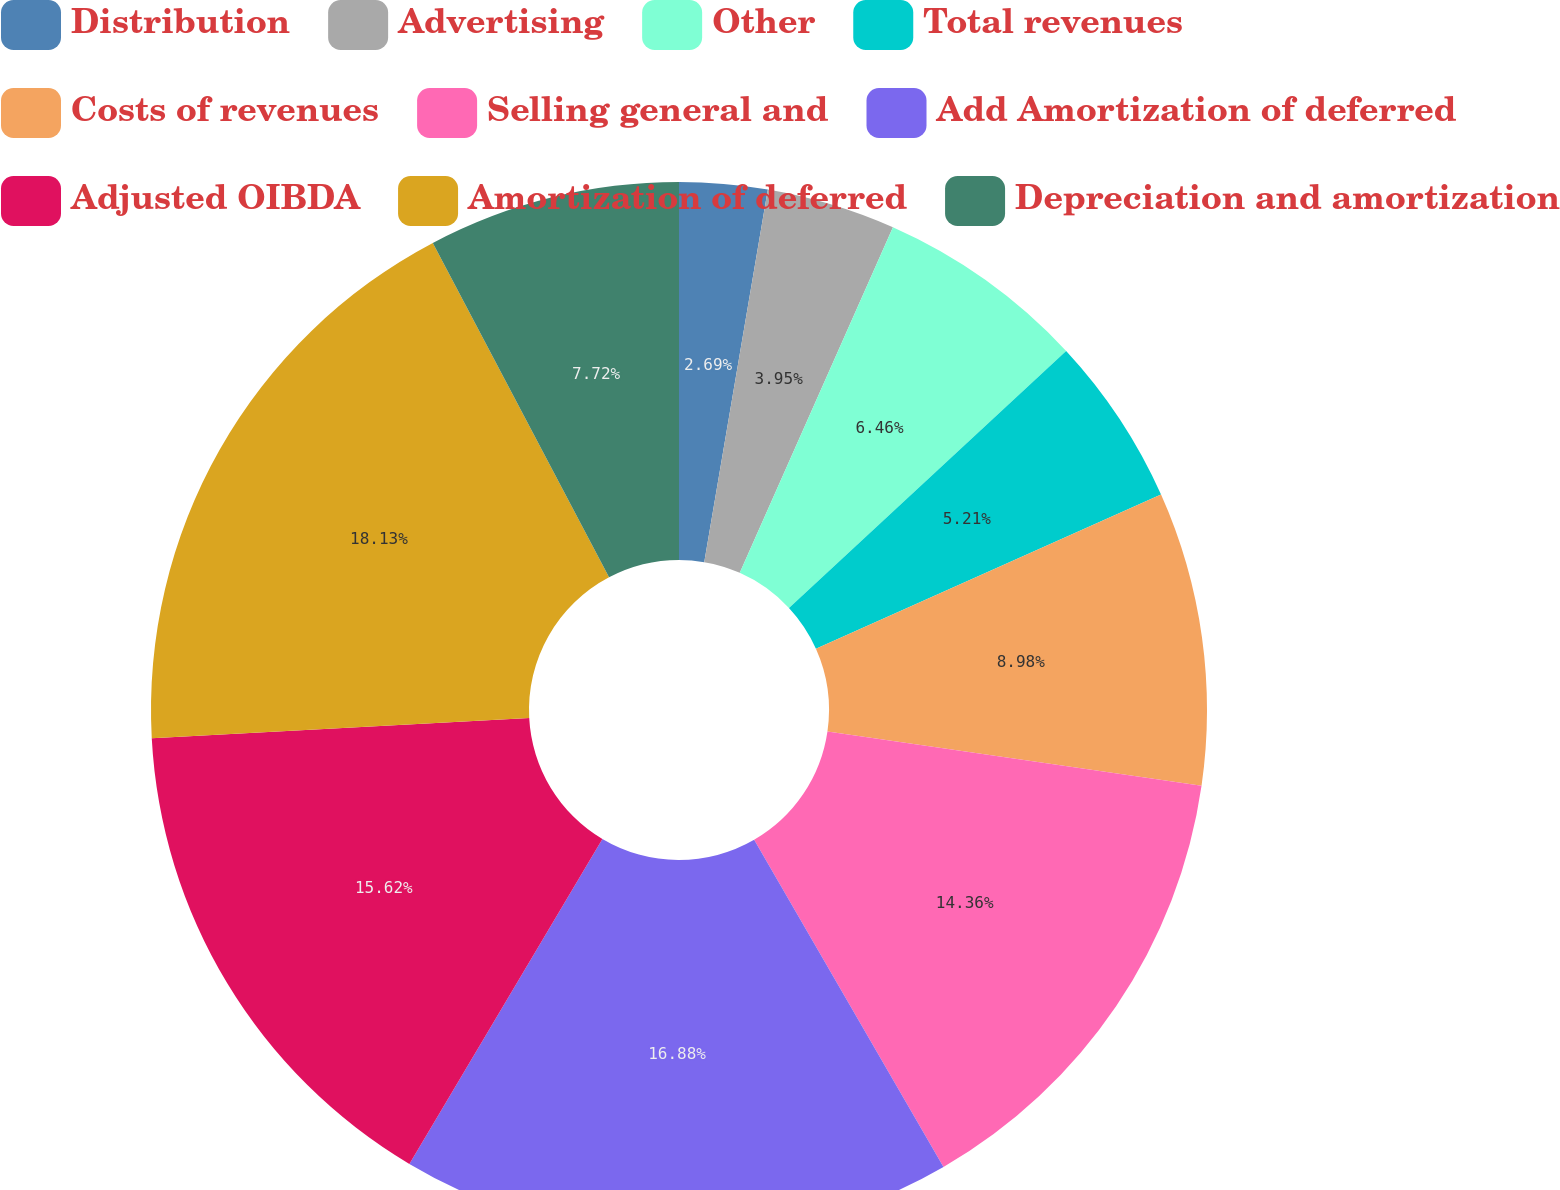<chart> <loc_0><loc_0><loc_500><loc_500><pie_chart><fcel>Distribution<fcel>Advertising<fcel>Other<fcel>Total revenues<fcel>Costs of revenues<fcel>Selling general and<fcel>Add Amortization of deferred<fcel>Adjusted OIBDA<fcel>Amortization of deferred<fcel>Depreciation and amortization<nl><fcel>2.69%<fcel>3.95%<fcel>6.46%<fcel>5.21%<fcel>8.98%<fcel>14.36%<fcel>16.88%<fcel>15.62%<fcel>18.13%<fcel>7.72%<nl></chart> 